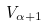<formula> <loc_0><loc_0><loc_500><loc_500>V _ { \alpha + 1 }</formula> 